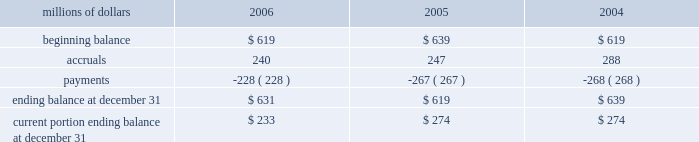Consolidated results of operations , financial condition , or liquidity ; however , to the extent possible , where unasserted claims are considered probable and where such claims can be reasonably estimated , we have recorded a liability .
We do not expect that any known lawsuits , claims , environmental costs , commitments , contingent liabilities , or guarantees will have a material adverse effect on our consolidated results of operations , financial condition , or liquidity after taking into account liabilities previously recorded for these matters .
Personal injury 2013 the cost of personal injuries to employees and others related to our activities is charged to expense based on estimates of the ultimate cost and number of incidents each year .
We use third-party actuaries to assist us in measuring the expense and liability , including unasserted claims .
Compensation for work-related accidents is governed by the federal employers 2019 liability act ( fela ) .
Under fela , damages are assessed based on a finding of fault through litigation or out-of-court settlements .
Our personal injury liability activity was as follows : millions of dollars 2006 2005 2004 .
Our personal injury liability is discounted to present value using applicable u.s .
Treasury rates .
Approximately 87% ( 87 % ) of the recorded liability related to asserted claims , and approximately 13% ( 13 % ) related to unasserted claims .
Personal injury accruals were higher in 2004 due to a 1998 crossing accident verdict upheld in 2004 and a 2004 derailment near san antonio .
Asbestos 2013 we are a defendant in a number of lawsuits in which current and former employees allege exposure to asbestos .
Additionally , we have received claims for asbestos exposure that have not been litigated .
The claims and lawsuits ( collectively referred to as 201cclaims 201d ) allege occupational illness resulting from exposure to asbestos- containing products .
In most cases , the claimants do not have credible medical evidence of physical impairment resulting from the alleged exposures .
Additionally , most claims filed against us do not specify an amount of alleged damages .
During 2004 , we engaged a third party with extensive experience in estimating resolution costs for asbestos- related claims to assist us in assessing the number and value of these unasserted claims through 2034 , based on our average claims experience over a multi-year period .
As a result , we increased our liability in 2004 for asbestos- related claims in the fourth quarter of 2004 .
The liability for resolving both asserted and unasserted claims was based on the following assumptions : 2022 the number of future claims received would be consistent with historical averages .
2022 the number of claims filed against us will decline each year .
2022 the average settlement values for asserted and unasserted claims will be equivalent to historical averages .
2022 the percentage of claims dismissed in the future will be equivalent to historical averages. .
In 2006 what was the percentage of the personal injury liability that was current as of december 31? 
Computations: (233 / 631)
Answer: 0.36926. Consolidated results of operations , financial condition , or liquidity ; however , to the extent possible , where unasserted claims are considered probable and where such claims can be reasonably estimated , we have recorded a liability .
We do not expect that any known lawsuits , claims , environmental costs , commitments , contingent liabilities , or guarantees will have a material adverse effect on our consolidated results of operations , financial condition , or liquidity after taking into account liabilities previously recorded for these matters .
Personal injury 2013 the cost of personal injuries to employees and others related to our activities is charged to expense based on estimates of the ultimate cost and number of incidents each year .
We use third-party actuaries to assist us in measuring the expense and liability , including unasserted claims .
Compensation for work-related accidents is governed by the federal employers 2019 liability act ( fela ) .
Under fela , damages are assessed based on a finding of fault through litigation or out-of-court settlements .
Our personal injury liability activity was as follows : millions of dollars 2006 2005 2004 .
Our personal injury liability is discounted to present value using applicable u.s .
Treasury rates .
Approximately 87% ( 87 % ) of the recorded liability related to asserted claims , and approximately 13% ( 13 % ) related to unasserted claims .
Personal injury accruals were higher in 2004 due to a 1998 crossing accident verdict upheld in 2004 and a 2004 derailment near san antonio .
Asbestos 2013 we are a defendant in a number of lawsuits in which current and former employees allege exposure to asbestos .
Additionally , we have received claims for asbestos exposure that have not been litigated .
The claims and lawsuits ( collectively referred to as 201cclaims 201d ) allege occupational illness resulting from exposure to asbestos- containing products .
In most cases , the claimants do not have credible medical evidence of physical impairment resulting from the alleged exposures .
Additionally , most claims filed against us do not specify an amount of alleged damages .
During 2004 , we engaged a third party with extensive experience in estimating resolution costs for asbestos- related claims to assist us in assessing the number and value of these unasserted claims through 2034 , based on our average claims experience over a multi-year period .
As a result , we increased our liability in 2004 for asbestos- related claims in the fourth quarter of 2004 .
The liability for resolving both asserted and unasserted claims was based on the following assumptions : 2022 the number of future claims received would be consistent with historical averages .
2022 the number of claims filed against us will decline each year .
2022 the average settlement values for asserted and unasserted claims will be equivalent to historical averages .
2022 the percentage of claims dismissed in the future will be equivalent to historical averages. .
What was the percentage change in personal injury liability from 2005 to 2006? 
Computations: ((631 - 619) / 619)
Answer: 0.01939. 